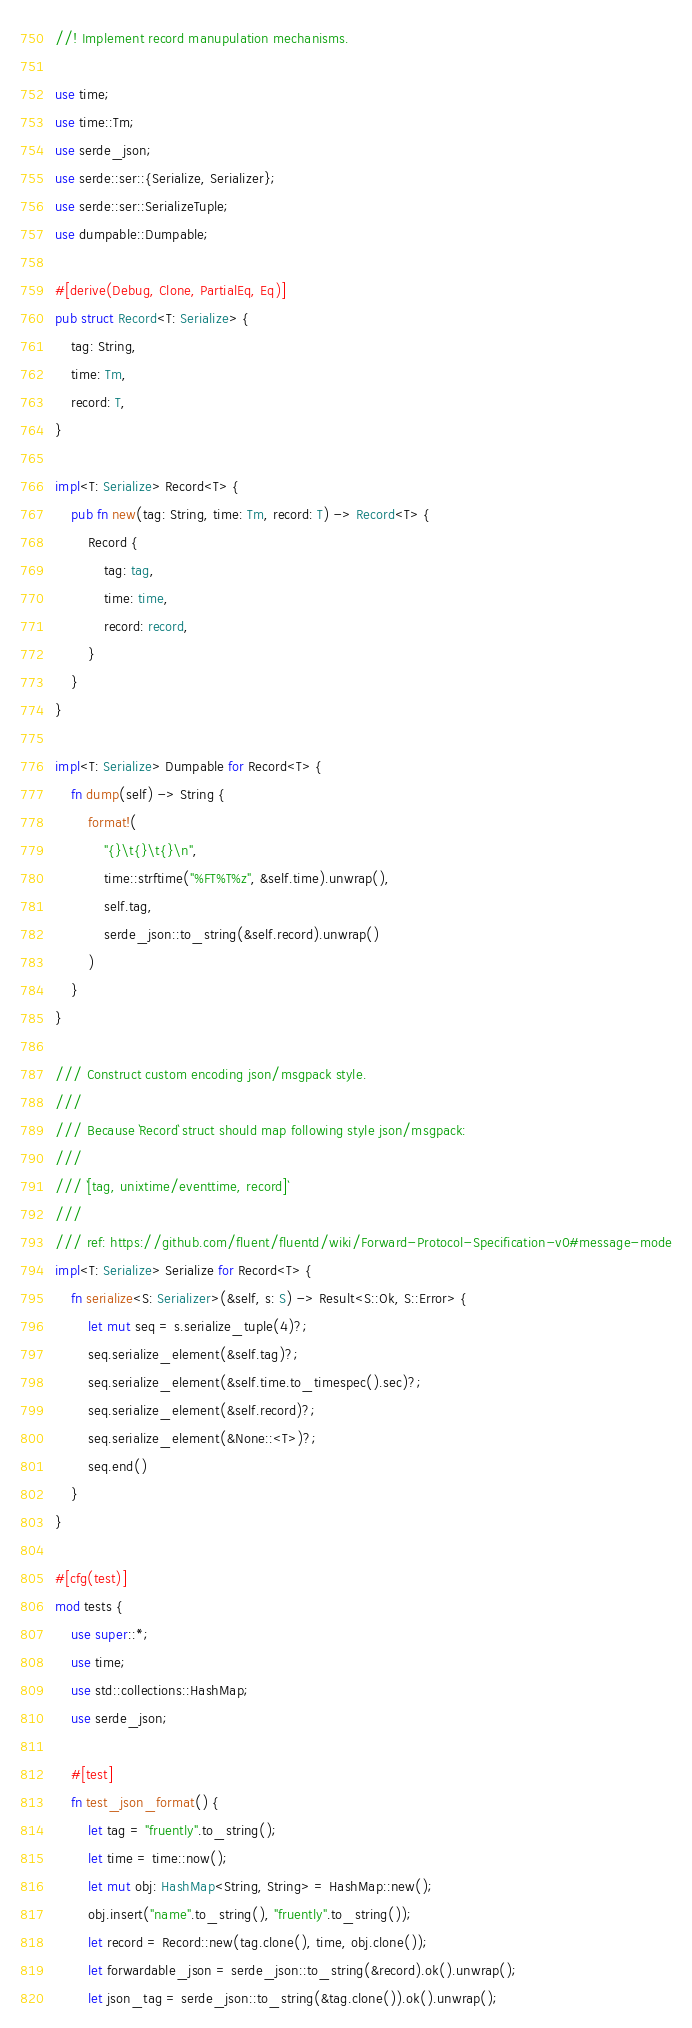<code> <loc_0><loc_0><loc_500><loc_500><_Rust_>//! Implement record manupulation mechanisms.

use time;
use time::Tm;
use serde_json;
use serde::ser::{Serialize, Serializer};
use serde::ser::SerializeTuple;
use dumpable::Dumpable;

#[derive(Debug, Clone, PartialEq, Eq)]
pub struct Record<T: Serialize> {
    tag: String,
    time: Tm,
    record: T,
}

impl<T: Serialize> Record<T> {
    pub fn new(tag: String, time: Tm, record: T) -> Record<T> {
        Record {
            tag: tag,
            time: time,
            record: record,
        }
    }
}

impl<T: Serialize> Dumpable for Record<T> {
    fn dump(self) -> String {
        format!(
            "{}\t{}\t{}\n",
            time::strftime("%FT%T%z", &self.time).unwrap(),
            self.tag,
            serde_json::to_string(&self.record).unwrap()
        )
    }
}

/// Construct custom encoding json/msgpack style.
///
/// Because `Record` struct should map following style json/msgpack:
///
/// `[tag, unixtime/eventtime, record]`
///
/// ref: https://github.com/fluent/fluentd/wiki/Forward-Protocol-Specification-v0#message-mode
impl<T: Serialize> Serialize for Record<T> {
    fn serialize<S: Serializer>(&self, s: S) -> Result<S::Ok, S::Error> {
        let mut seq = s.serialize_tuple(4)?;
        seq.serialize_element(&self.tag)?;
        seq.serialize_element(&self.time.to_timespec().sec)?;
        seq.serialize_element(&self.record)?;
        seq.serialize_element(&None::<T>)?;
        seq.end()
    }
}

#[cfg(test)]
mod tests {
    use super::*;
    use time;
    use std::collections::HashMap;
    use serde_json;

    #[test]
    fn test_json_format() {
        let tag = "fruently".to_string();
        let time = time::now();
        let mut obj: HashMap<String, String> = HashMap::new();
        obj.insert("name".to_string(), "fruently".to_string());
        let record = Record::new(tag.clone(), time, obj.clone());
        let forwardable_json = serde_json::to_string(&record).ok().unwrap();
        let json_tag = serde_json::to_string(&tag.clone()).ok().unwrap();</code> 